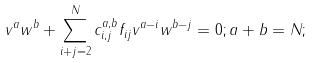<formula> <loc_0><loc_0><loc_500><loc_500>v ^ { a } w ^ { b } + \sum _ { i + j = 2 } ^ { N } c _ { i , j } ^ { a , b } f _ { i j } v ^ { a - i } w ^ { b - j } = 0 ; a + b = N ;</formula> 